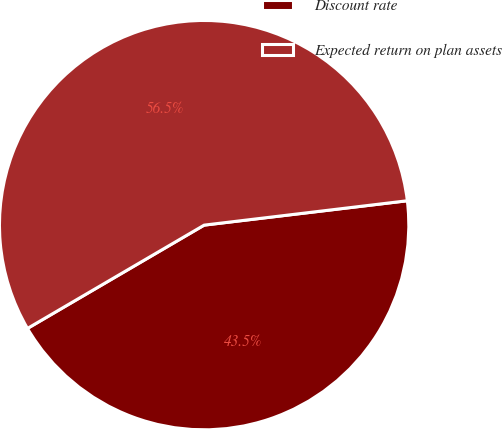Convert chart. <chart><loc_0><loc_0><loc_500><loc_500><pie_chart><fcel>Discount rate<fcel>Expected return on plan assets<nl><fcel>43.48%<fcel>56.52%<nl></chart> 